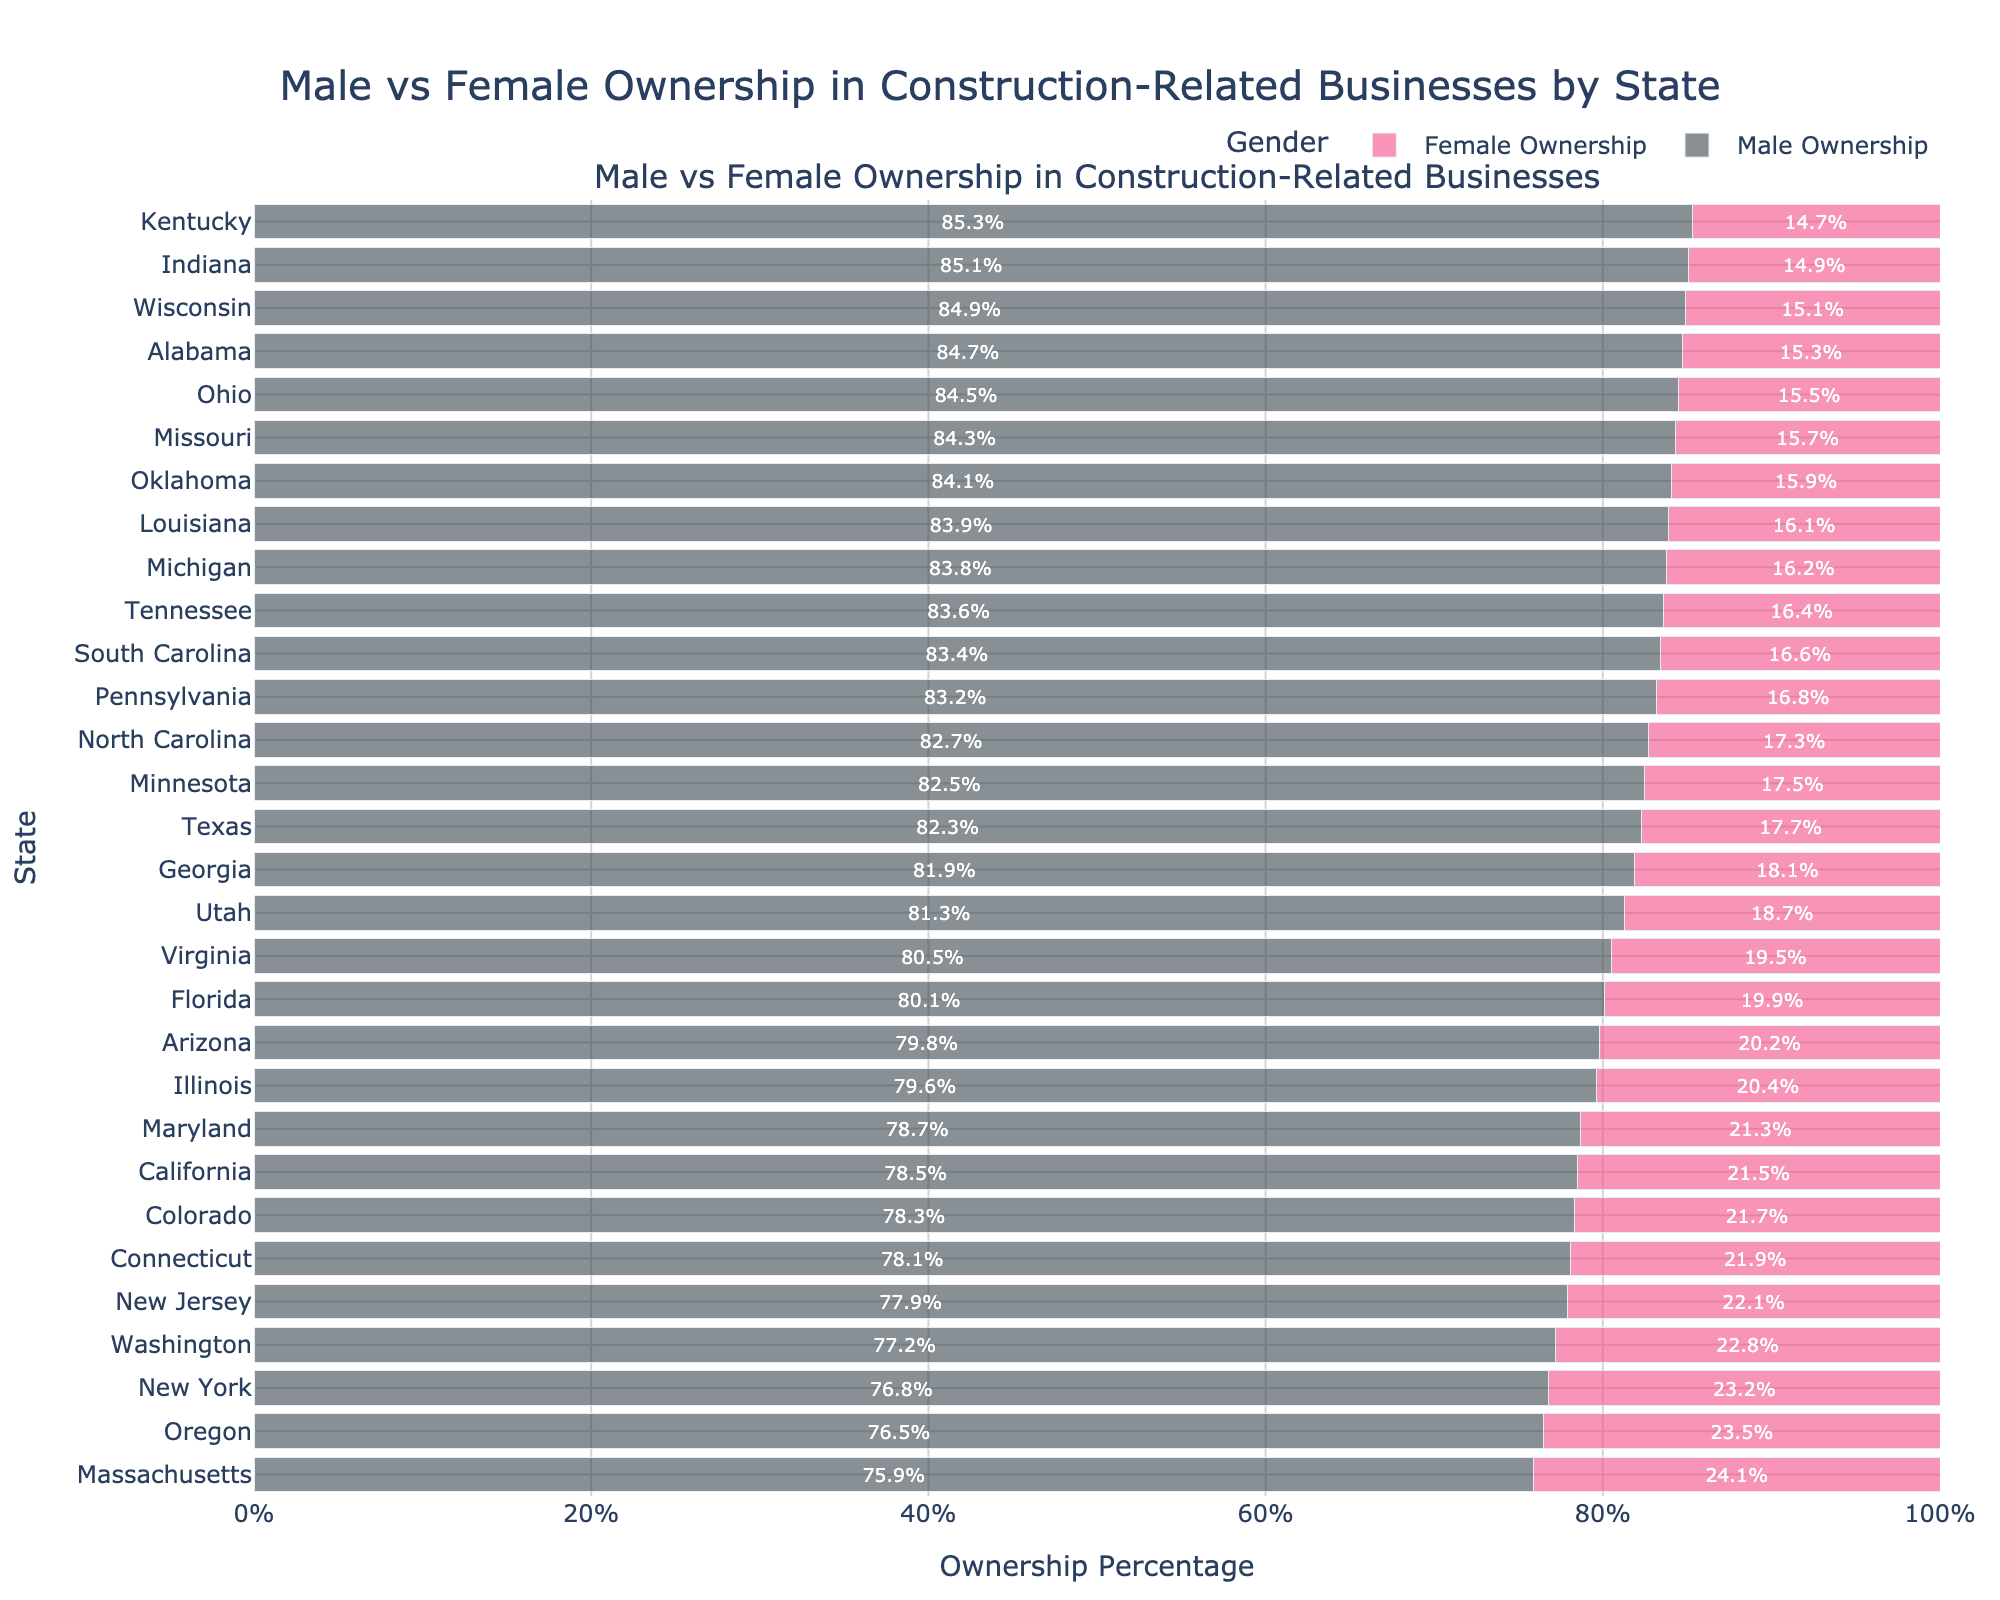Which state has the highest percentage of female-owned construction businesses? The bar chart shows "Massachusetts" with the highest percentage of female ownership at 24.1%, indicated by the longest length of the pink bar.
Answer: Massachusetts Which state has the lowest percentage of female-owned construction businesses? Observing the chart, "Kentucky" has the lowest percentage of female ownership at 14.7%, indicated by the shortest pink bar.
Answer: Kentucky How does female ownership in California compare to New York? The chart shows California at 21.5% and New York at 23.2%. By comparing the lengths of the pink bars, New York has a higher percentage of female ownership than California.
Answer: New York What is the average percentage of male ownership in the top five states with the highest female ownership? Top five states by female ownership: Massachusetts (24.1%), Oregon (23.5%), New York (23.2%), Washington (22.8%), and New Jersey (22.1%). Their male ownership percentages are 75.9%, 76.5%, 76.8%, 77.2%, and 77.9%, respectively. Average = (75.9 + 76.5 + 76.8 + 77.2 + 77.9)/5 = 76.86%.
Answer: 76.86% Identify two states where male ownership exceeds 85%. Observing the chart, "Indiana" and "Kentucky" both exceed 85% male ownership, indicated by the very long blue bars.
Answer: Indiana and Kentucky What is the difference in female ownership percentage between Virginia and Wisconsin? Virginia has 19.5% female ownership, and Wisconsin has 15.1%. The difference is 19.5% - 15.1% = 4.4%.
Answer: 4.4% Which two states have closest female ownership percentages? "Louisiana" (16.1%) and "Michigan" (16.2%) have very similar female ownership percentages, indicated by the nearly equal lengths of their pink bars.
Answer: Louisiana and Michigan In which state is the total ownership percentage closest to 100% exactly divided between males and females? Considering states where male and female ownership percentages sum closest to 100% each, "Oregon" with 76.5% male and 23.5% female totals exactly 100%.
Answer: Oregon Do more states have male ownership percentages greater than or equal to 80% or less than 80%? From the chart, count all states with male ownership >= 80% and < 80%. There are 18 states with >= 80% and 12 states with < 80%.
Answer: Greater than or equal to 80% Which state has the highest difference between male and female ownership percentages? "Indiana" has 85.1% male and 14.9% female, with a difference of 85.1% - 14.9% = 70.2%, which is the highest.
Answer: Indiana 